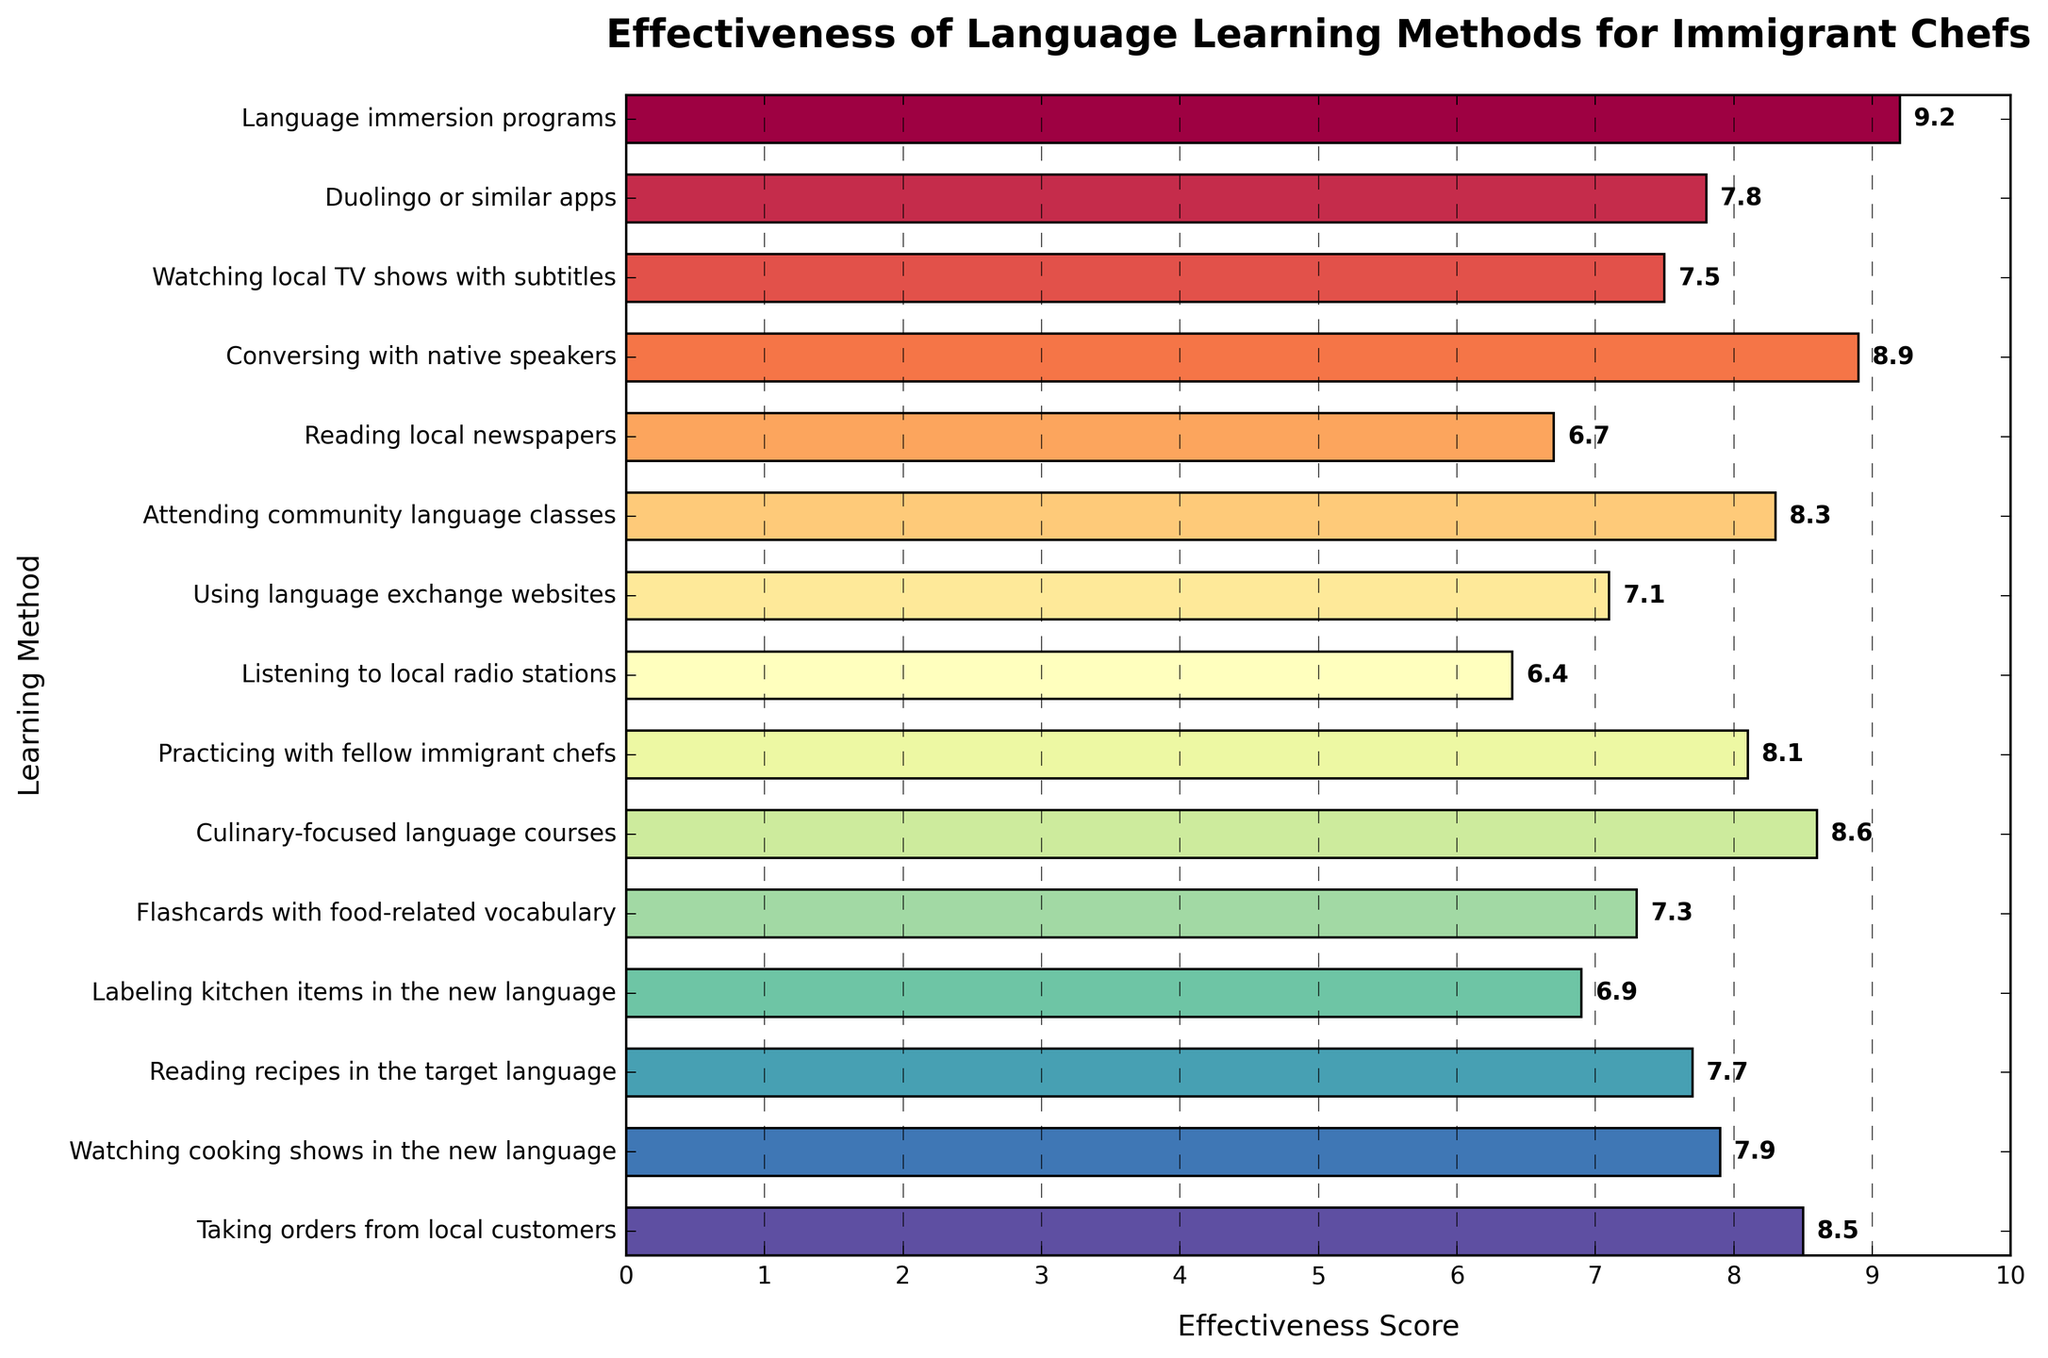What's the most effective language learning method according to the chart? Look for the method with the highest effectiveness score on the chart. "Language immersion programs" have the highest score of 9.2.
Answer: Language immersion programs Which has a higher effectiveness score: practicing with fellow immigrant chefs or Duolingo or similar apps? Compare the effectiveness score of "Practicing with fellow immigrant chefs" (8.1) with "Duolingo or similar apps" (7.8). The former is higher.
Answer: Practicing with fellow immigrant chefs What is the difference in effectiveness score between watching cooking shows in the new language and using language exchange websites? Find the effectiveness scores for both methods ("Watching cooking shows in the new language" - 7.9 and "Using language exchange websites" - 7.1) and calculate the difference: 7.9 - 7.1 = 0.8.
Answer: 0.8 Which method is less effective: reading recipes in the target language or labeling kitchen items in the new language? Compare the effectiveness scores of "Reading recipes in the target language" (7.7) and "Labeling kitchen items in the new language" (6.9). The latter is less effective.
Answer: Labeling kitchen items in the new language Which method has an effectiveness score equal to or greater than 8.0 but less than 8.5? List all such methods. Identify the methods with scores between 8.0 and 8.5 (inclusive for 8.0 but exclusive for 8.5): "Attending community language classes" (8.3), "Practicing with fellow immigrant chefs" (8.1).
Answer: Attending community language classes, Practicing with fellow immigrant chefs How many learning methods have an effectiveness score of 7.0 or higher? Count the number of methods with scores of at least 7.0. They are: "Language immersion programs", "Duolingo or similar apps", "Watching local TV shows with subtitles", "Conversing with native speakers", "Attending community language classes", "Practicing with fellow immigrant chefs", "Culinary-focused language courses", "Flashcards with food-related vocabulary", "Reading recipes in the target language", "Watching cooking shows in the new language", "Taking orders from local customers". There are 11 methods.
Answer: 11 What is the median effectiveness score of all the methods? List all the effectiveness scores in ascending order and find the middle score. The scores are: 6.4, 6.7, 6.9, 7.1, 7.3, 7.5, 7.7, 7.8, 7.9, 8.1, 8.3, 8.5, 8.6, 8.9, 9.2. The middle score (median) is 7.7.
Answer: 7.7 Which methods have the same effectiveness score? Look for methods with the same effectiveness score. "Reading recipes in the target language" (7.7) and "Watching local TV shows with subtitles" (7.5) do not match with any others; so, there are no methods with exactly the same score.
Answer: None 